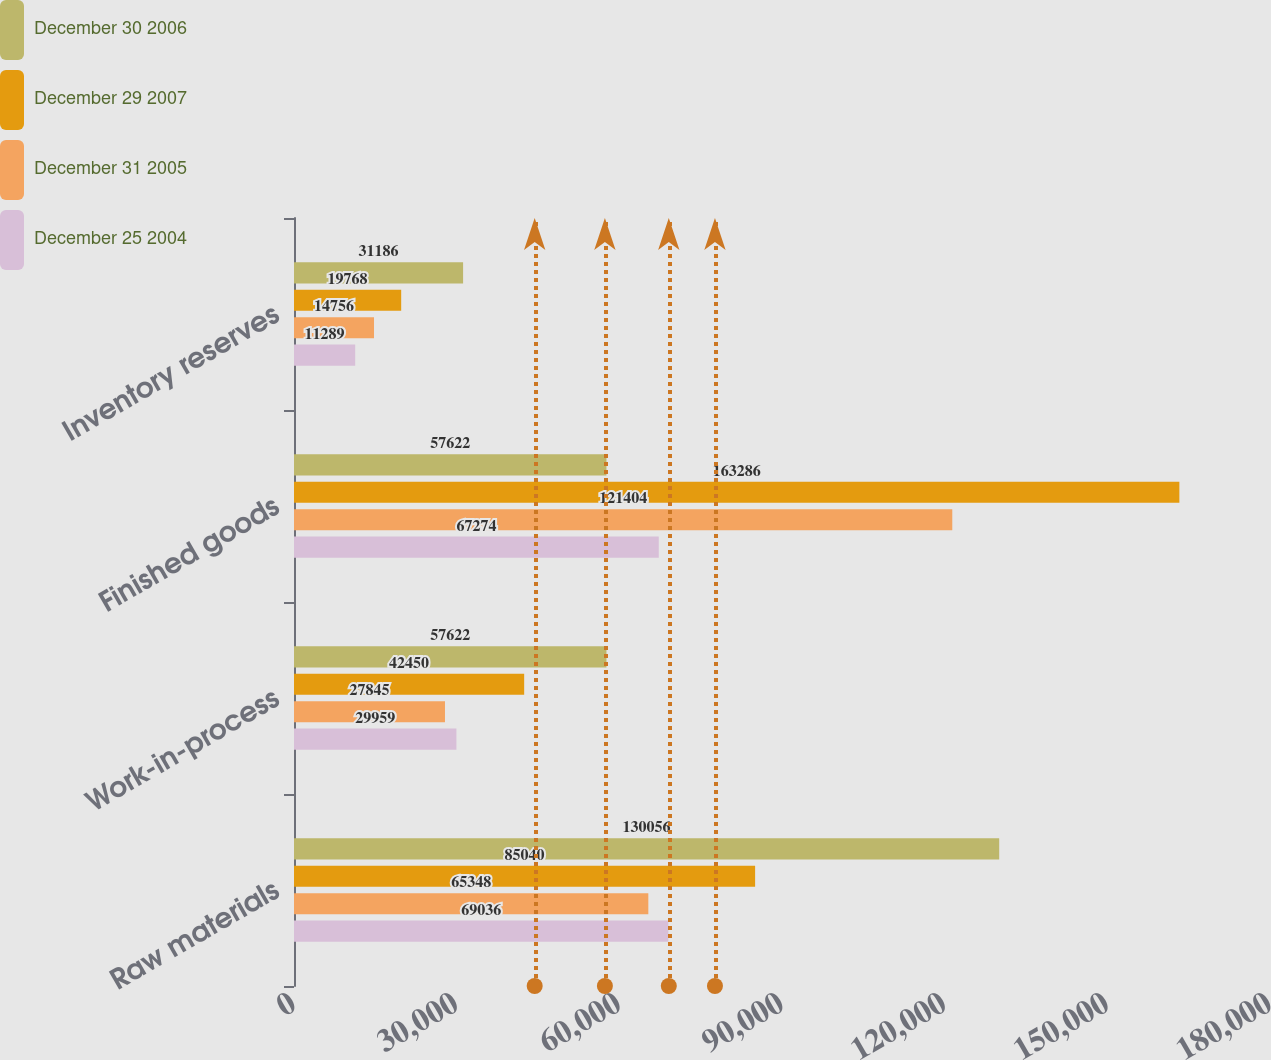Convert chart. <chart><loc_0><loc_0><loc_500><loc_500><stacked_bar_chart><ecel><fcel>Raw materials<fcel>Work-in-process<fcel>Finished goods<fcel>Inventory reserves<nl><fcel>December 30 2006<fcel>130056<fcel>57622<fcel>57622<fcel>31186<nl><fcel>December 29 2007<fcel>85040<fcel>42450<fcel>163286<fcel>19768<nl><fcel>December 31 2005<fcel>65348<fcel>27845<fcel>121404<fcel>14756<nl><fcel>December 25 2004<fcel>69036<fcel>29959<fcel>67274<fcel>11289<nl></chart> 